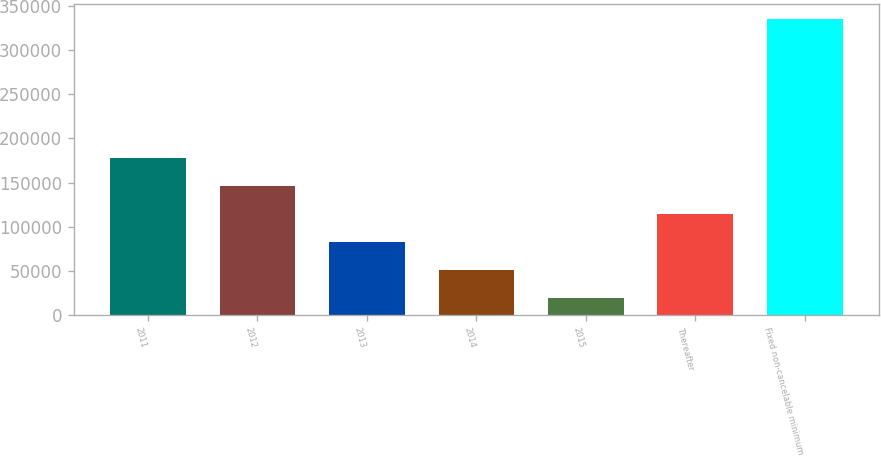Convert chart to OTSL. <chart><loc_0><loc_0><loc_500><loc_500><bar_chart><fcel>2011<fcel>2012<fcel>2013<fcel>2014<fcel>2015<fcel>Thereafter<fcel>Fixed non-cancelable minimum<nl><fcel>177356<fcel>145767<fcel>82586.8<fcel>50996.9<fcel>19407<fcel>114177<fcel>335306<nl></chart> 